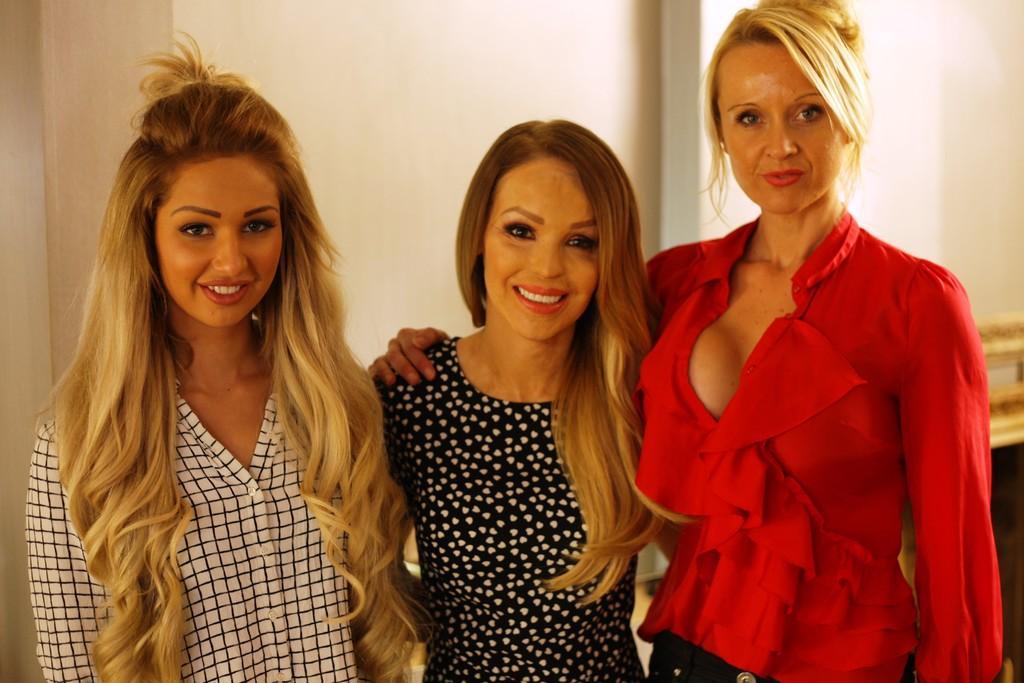How would you summarize this image in a sentence or two? In the picture I can see a woman wearing a red color dress is standing on the right side of the image and a woman wearing wearing a white color dress is standing on the left side of the image. Here we can see a woman wearing a black color dress is at the center of the image. These three women are smiling. In the background, we can see the white color wall. 